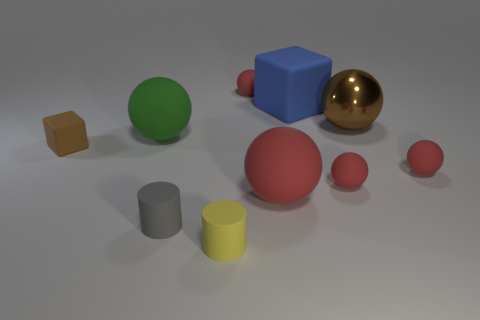How many red things are large metallic balls or tiny rubber things? Within the image, we observe one large metallic ball that is gold, not red, and three small rubber items that are red in color. Therefore, focusing solely on the red objects described in the question, there are three items that meet the criteria. 